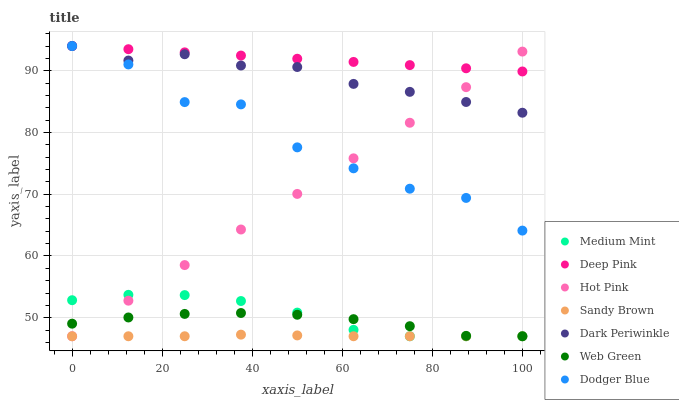Does Sandy Brown have the minimum area under the curve?
Answer yes or no. Yes. Does Deep Pink have the maximum area under the curve?
Answer yes or no. Yes. Does Hot Pink have the minimum area under the curve?
Answer yes or no. No. Does Hot Pink have the maximum area under the curve?
Answer yes or no. No. Is Hot Pink the smoothest?
Answer yes or no. Yes. Is Dodger Blue the roughest?
Answer yes or no. Yes. Is Deep Pink the smoothest?
Answer yes or no. No. Is Deep Pink the roughest?
Answer yes or no. No. Does Medium Mint have the lowest value?
Answer yes or no. Yes. Does Deep Pink have the lowest value?
Answer yes or no. No. Does Dark Periwinkle have the highest value?
Answer yes or no. Yes. Does Hot Pink have the highest value?
Answer yes or no. No. Is Sandy Brown less than Deep Pink?
Answer yes or no. Yes. Is Deep Pink greater than Web Green?
Answer yes or no. Yes. Does Web Green intersect Hot Pink?
Answer yes or no. Yes. Is Web Green less than Hot Pink?
Answer yes or no. No. Is Web Green greater than Hot Pink?
Answer yes or no. No. Does Sandy Brown intersect Deep Pink?
Answer yes or no. No. 